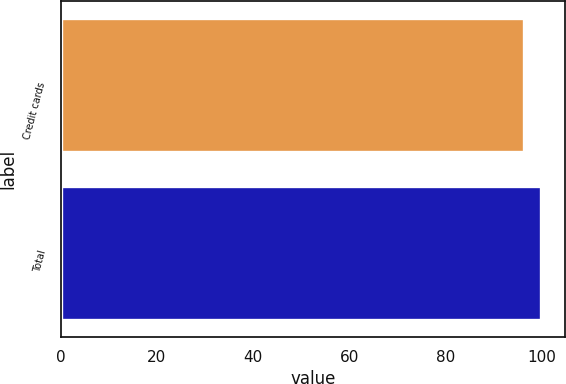<chart> <loc_0><loc_0><loc_500><loc_500><bar_chart><fcel>Credit cards<fcel>Total<nl><fcel>96.3<fcel>100<nl></chart> 